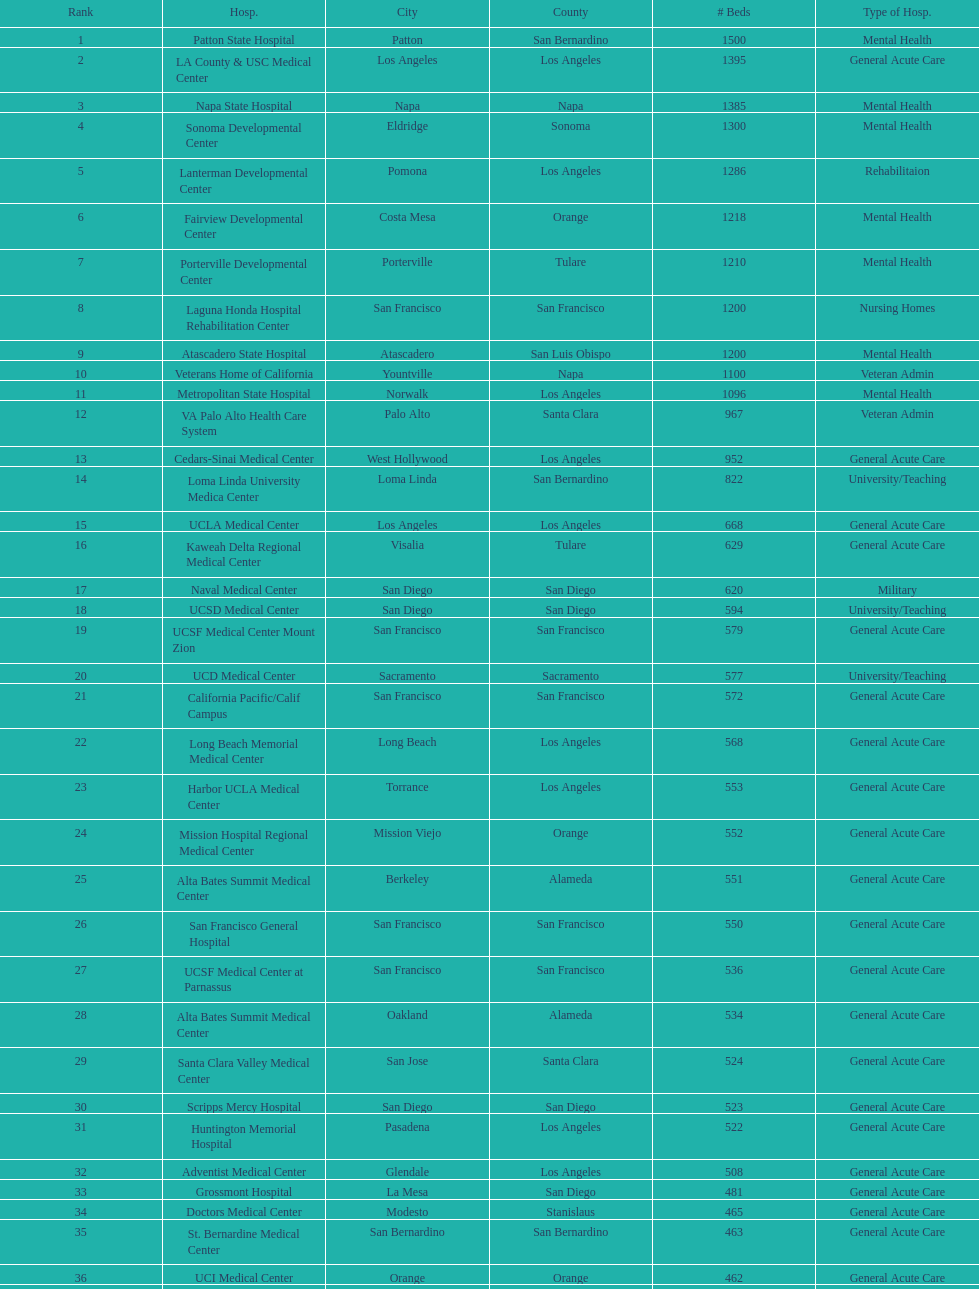What hospital in los angeles county providing hospital beds specifically for rehabilitation is ranked at least among the top 10 hospitals? Lanterman Developmental Center. 